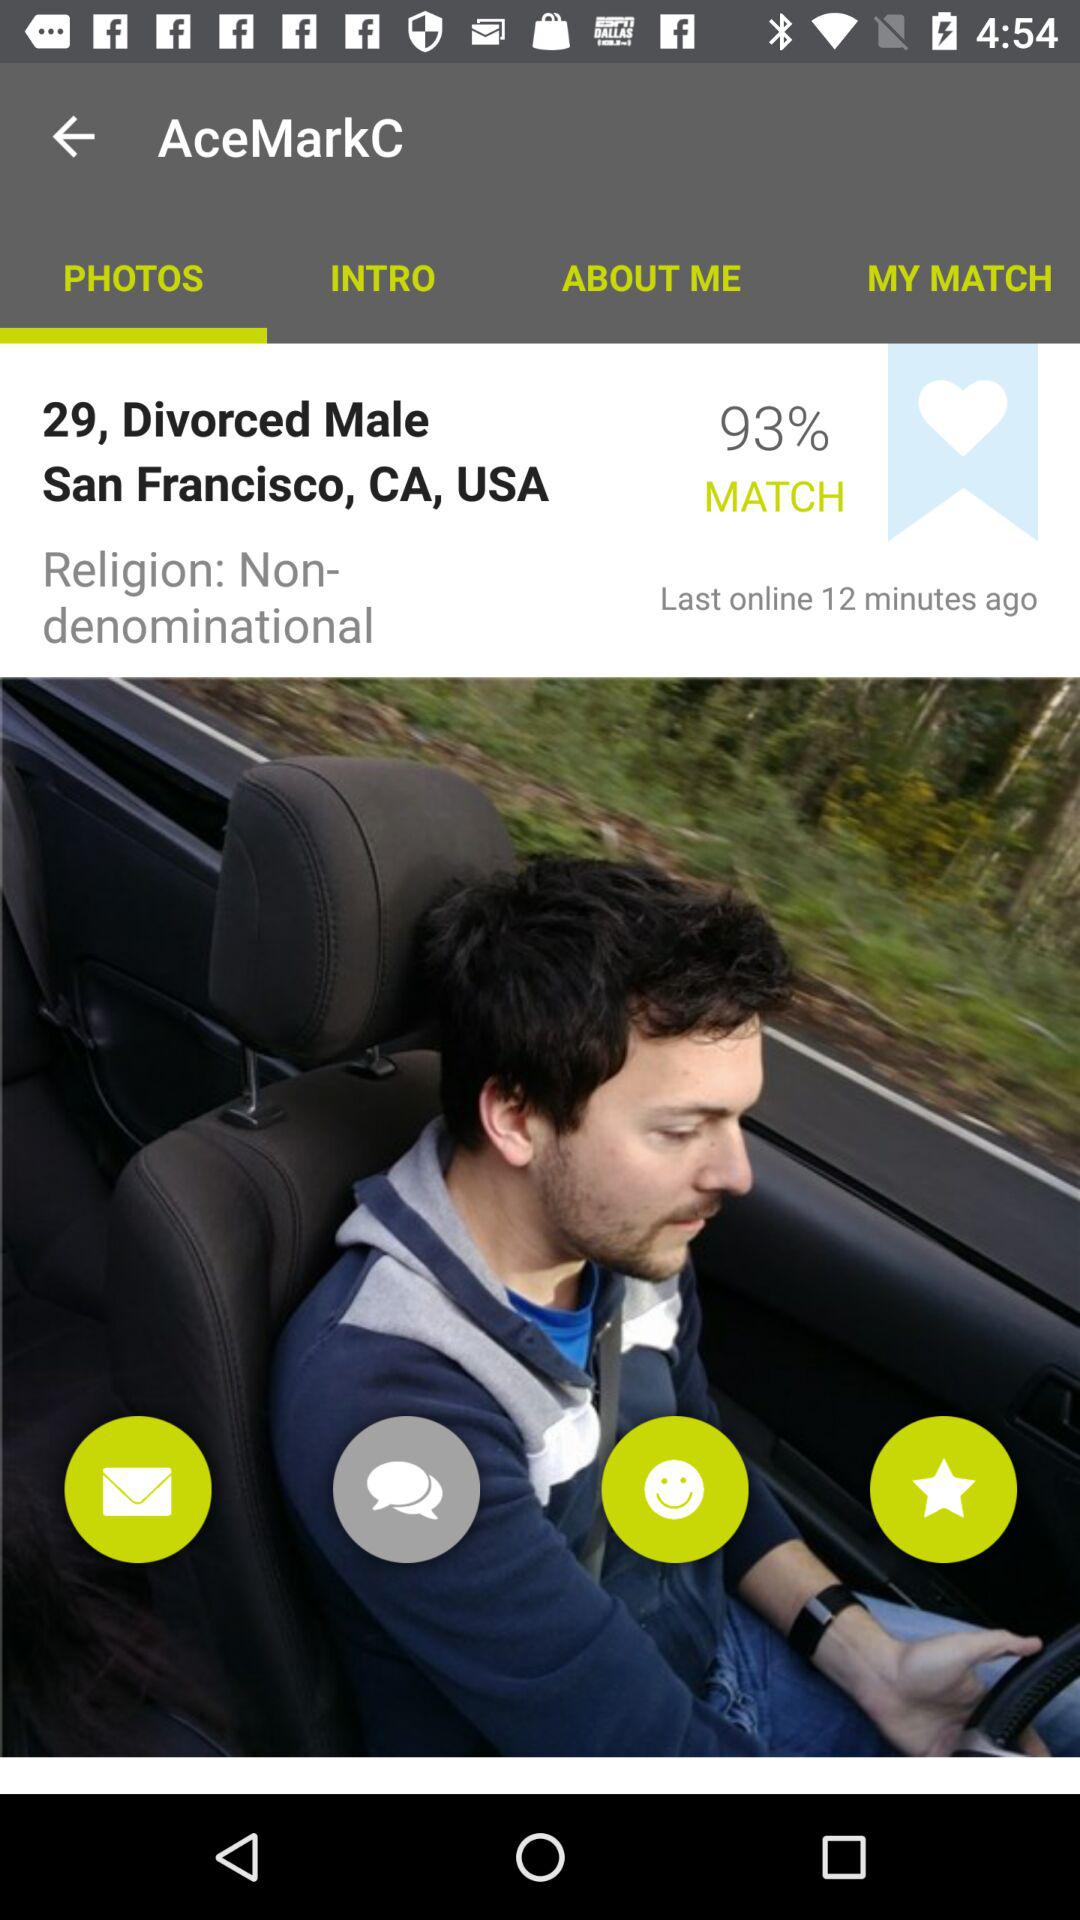How many minutes ago was the user online? The user was online 12 minutes ago. 